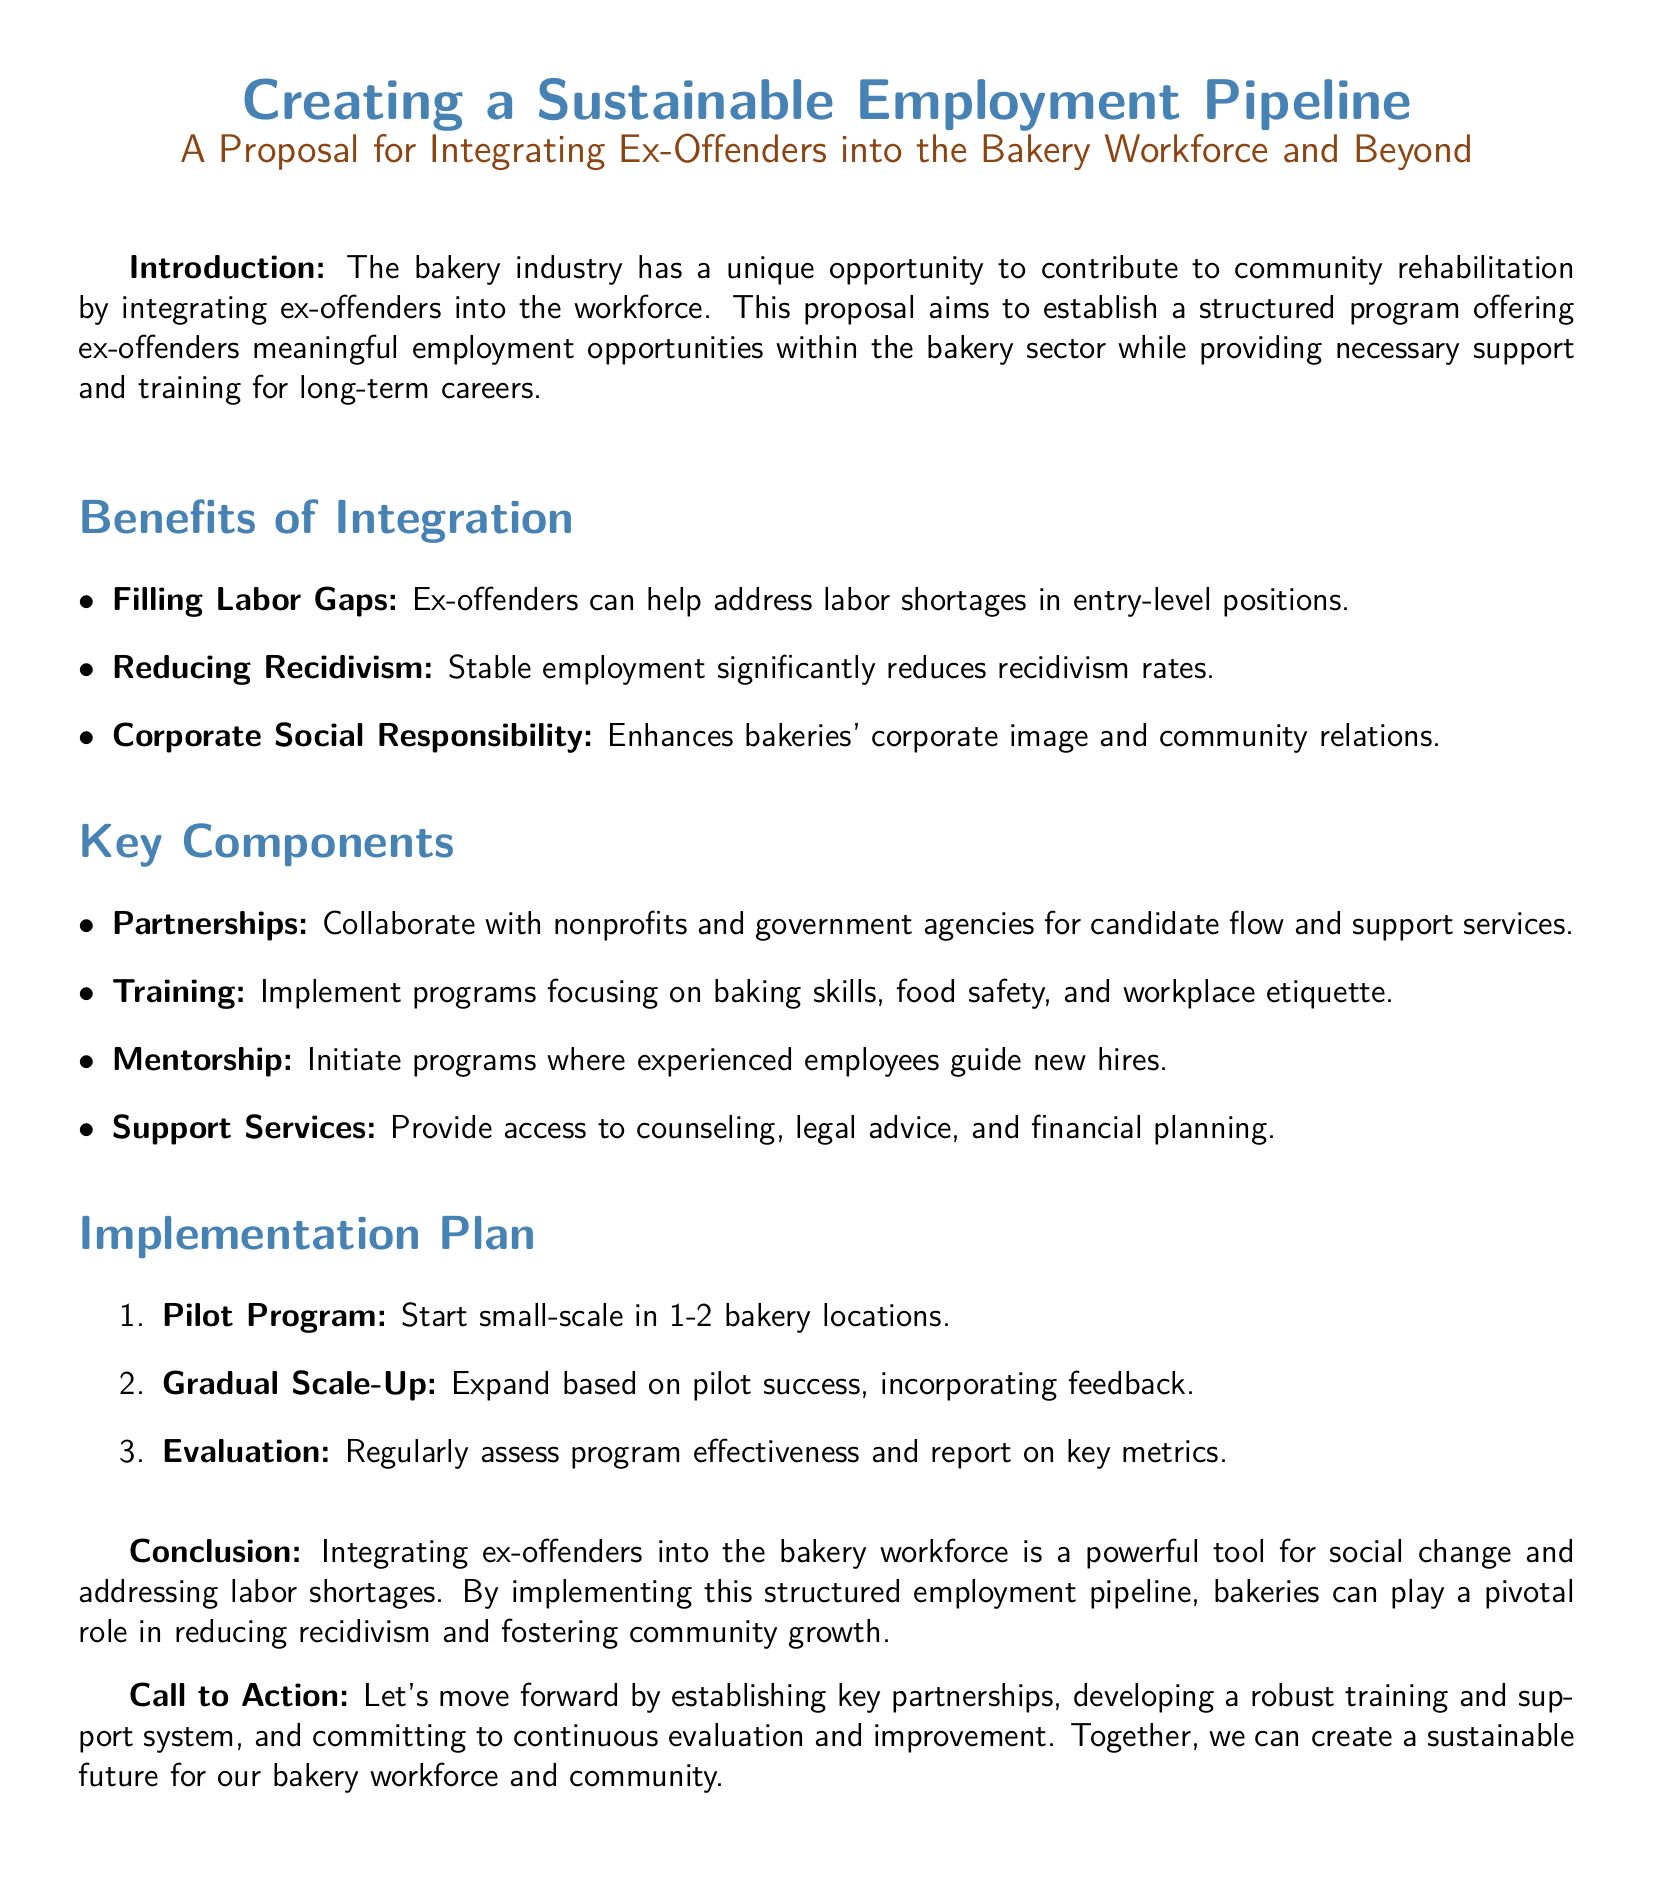What is the main goal of the proposal? The main goal is to establish a structured program offering ex-offenders meaningful employment opportunities within the bakery sector.
Answer: Structured program What are two benefits of integrating ex-offenders? Two benefits mentioned are filling labor gaps and reducing recidivism.
Answer: Filling labor gaps, reducing recidivism What is one key component of the proposal? One key component is partnerships with nonprofits and government agencies for candidate flow and support services.
Answer: Partnerships What scale is the pilot program suggested to start at? The pilot program is suggested to start small-scale in 1-2 bakery locations.
Answer: 1-2 bakery locations What color is used for section titles in the document? The section titles are styled in bakery blue.
Answer: Bakery blue What action does the proposal call for at the end? The proposal calls for establishing key partnerships and developing a robust training and support system.
Answer: Establishing key partnerships What is one support service offered in the program? One support service provided is access to counseling.
Answer: Counseling How often will the program effectiveness be assessed? The proposal states that program effectiveness will be regularly assessed.
Answer: Regularly What is the anticipated outcome of integrating ex-offenders into the workforce? The anticipated outcome is reducing recidivism and fostering community growth.
Answer: Reducing recidivism and fostering community growth 